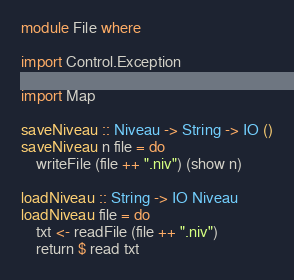<code> <loc_0><loc_0><loc_500><loc_500><_Haskell_>module File where

import Control.Exception

import Map

saveNiveau :: Niveau -> String -> IO ()
saveNiveau n file = do
    writeFile (file ++ ".niv") (show n)

loadNiveau :: String -> IO Niveau
loadNiveau file = do
    txt <- readFile (file ++ ".niv")
    return $ read txt
</code> 